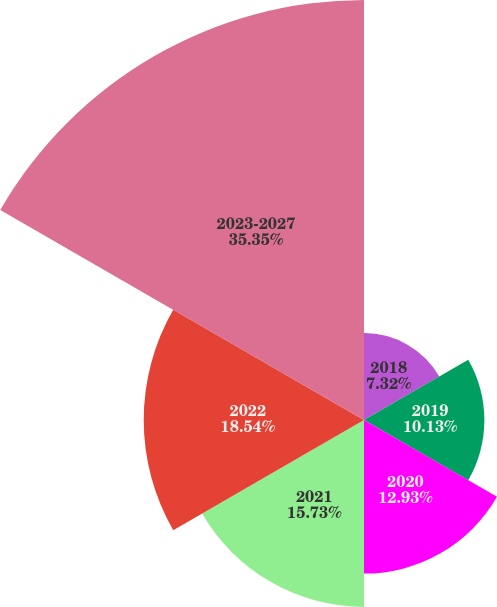Convert chart to OTSL. <chart><loc_0><loc_0><loc_500><loc_500><pie_chart><fcel>2018<fcel>2019<fcel>2020<fcel>2021<fcel>2022<fcel>2023-2027<nl><fcel>7.32%<fcel>10.13%<fcel>12.93%<fcel>15.73%<fcel>18.54%<fcel>35.35%<nl></chart> 